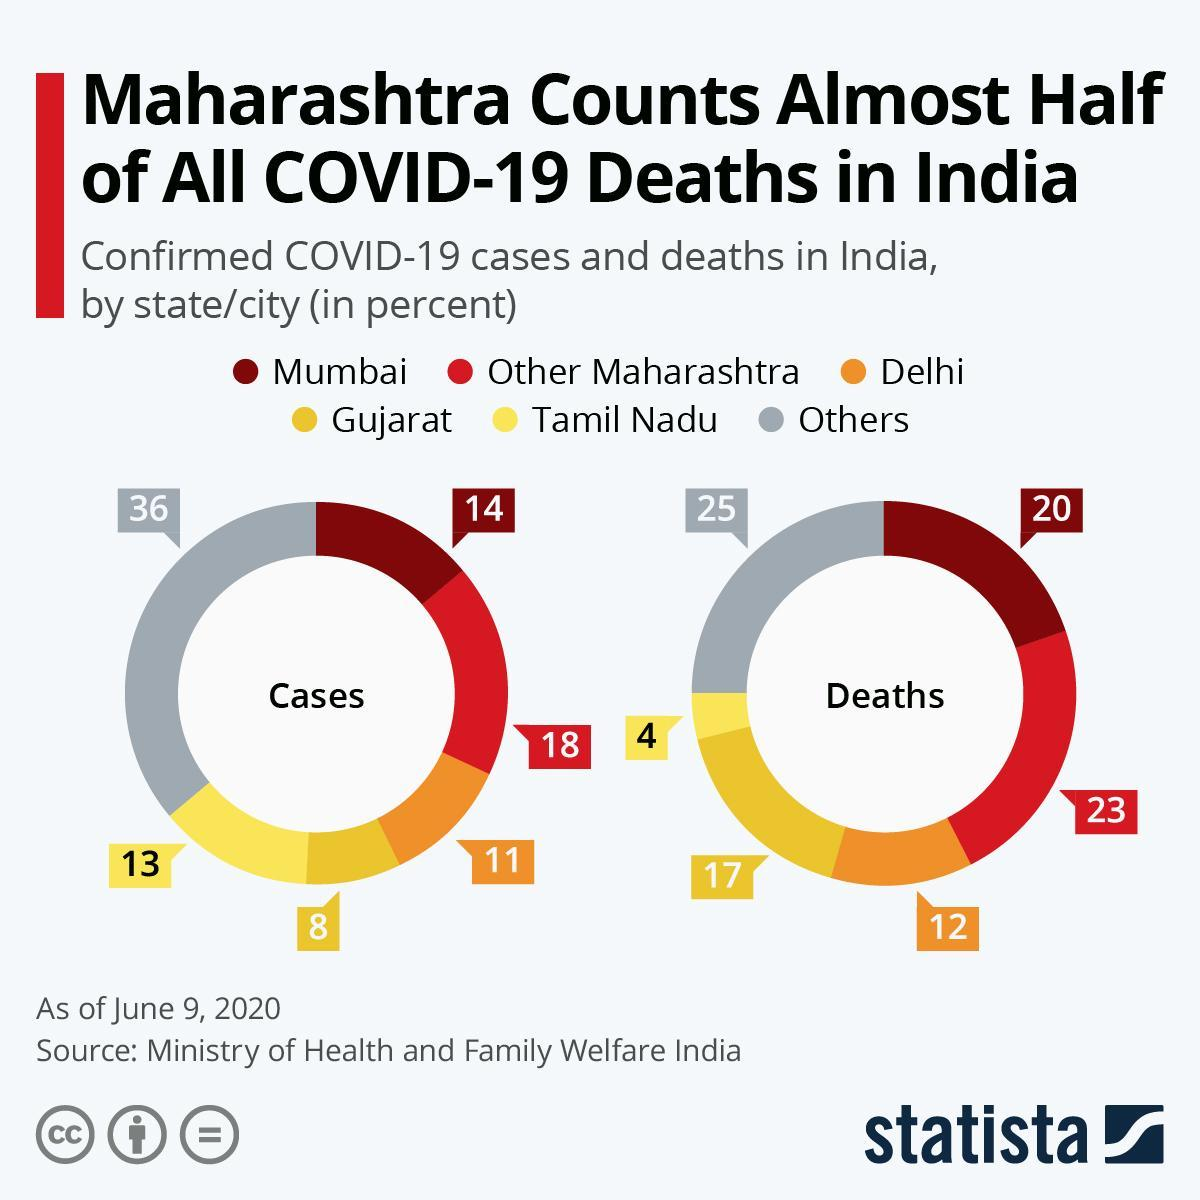Which place had the least number of cases among the ones listed?
Answer the question with a short phrase. Gujarat Which place had second highest number of deaths? Other Maharashtra 